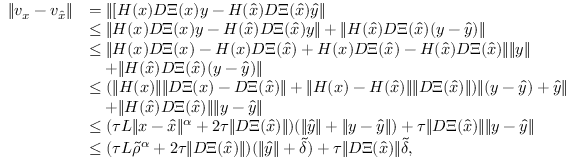Convert formula to latex. <formula><loc_0><loc_0><loc_500><loc_500>\begin{array} { r l } { \| v _ { x } - v _ { \hat { x } } \| } & { = \| [ H ( x ) D \Xi ( x ) y - H ( \hat { x } ) D \Xi ( \hat { x } ) \hat { y } \| } \\ & { \leq \| H ( x ) D \Xi ( x ) y - H ( \hat { x } ) D \Xi ( \hat { x } ) { y } \| + \| H ( \hat { x } ) D \Xi ( \hat { x } ) ( y - \hat { y } ) \| } \\ & { \leq \| H ( { x } ) D \Xi ( x ) - H ( { x } ) D \Xi ( \hat { x } ) + H ( { x } ) D \Xi ( \hat { x } ) - H ( \hat { x } ) D \Xi ( \hat { x } ) \| \| { y } \| } \\ & { \quad + \| H ( \hat { x } ) D \Xi ( \hat { x } ) ( y - \hat { y } ) \| } \\ & { \leq ( \| H ( { x } ) \| \| D \Xi ( x ) - D \Xi ( \hat { x } ) \| + \| H ( { x } ) - H ( \hat { x } ) \| \| D \Xi ( \hat { x } ) \| ) \| ( y - \hat { y } ) + \hat { y } \| } \\ & { \quad + \| H ( \hat { x } ) D \Xi ( \hat { x } ) \| \| y - \hat { y } \| } \\ & { \leq ( \tau L \| x - \hat { x } \| ^ { \alpha } + 2 \tau \| D \Xi ( \hat { x } ) \| ) ( \| \hat { y } \| + \| y - \hat { y } \| ) + \tau \| D \Xi ( \hat { x } ) \| \| y - \hat { y } \| } \\ & { \leq ( \tau L \tilde { \rho } ^ { \alpha } + 2 \tau \| D \Xi ( \hat { x } ) \| ) ( \| \hat { y } \| + \tilde { \delta } ) + \tau \| D \Xi ( \hat { x } ) \| \tilde { \delta } , } \end{array}</formula> 